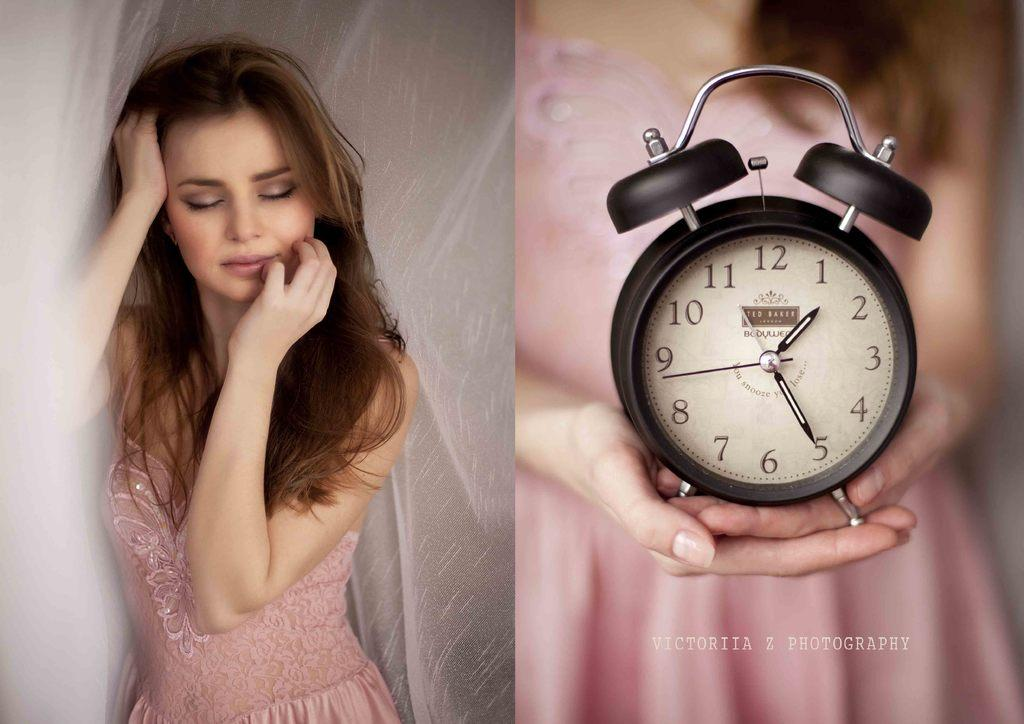<image>
Relay a brief, clear account of the picture shown. Girl in a pick dress holding a clock by Victoriia Z Photigraphy 